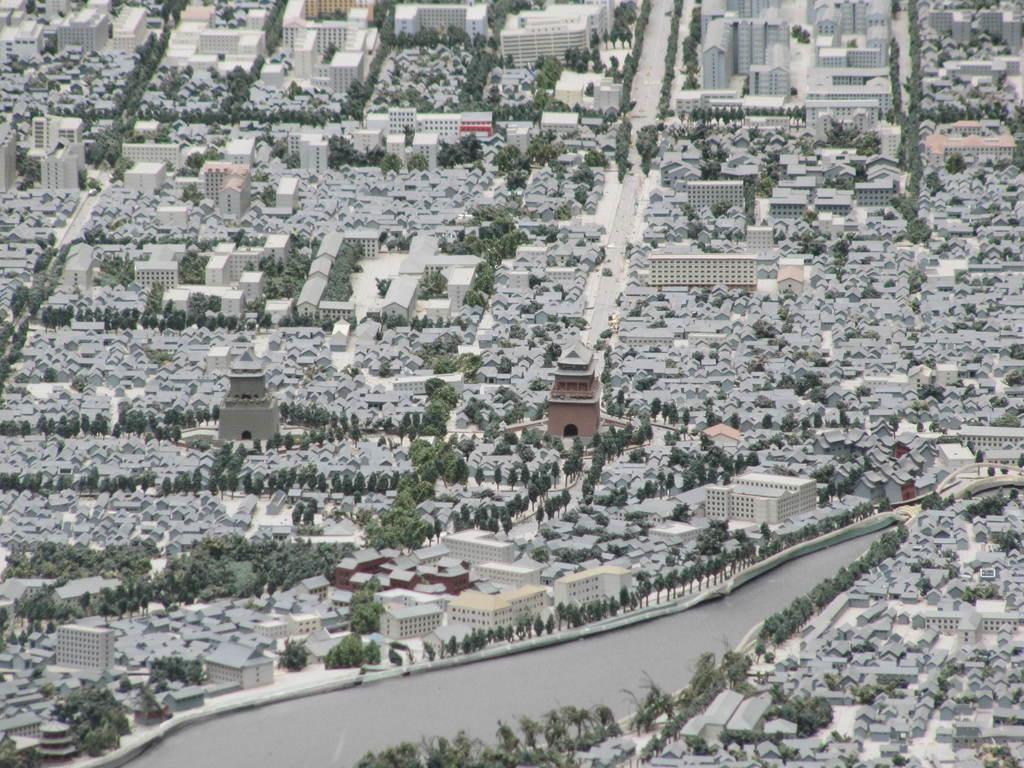Describe this image in one or two sentences. In this image I can see the water, few trees which are green in color and roofs of number of buildings which are grey in color. I can see the road. 